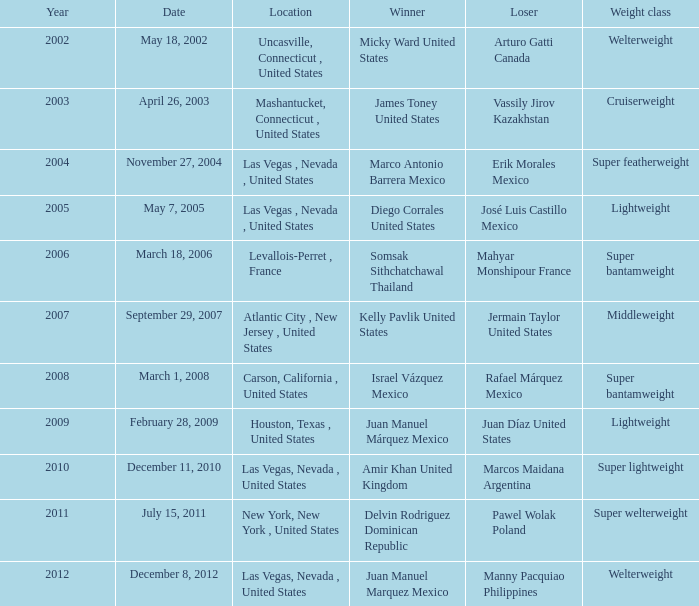How many years were lightweight class on february 28, 2009? 1.0. 